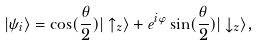Convert formula to latex. <formula><loc_0><loc_0><loc_500><loc_500>| \psi _ { i } \rangle = \cos ( \frac { \theta } { 2 } ) | \uparrow _ { z } \rangle + e ^ { i \varphi } \sin ( \frac { \theta } { 2 } ) | \downarrow _ { z } \rangle ,</formula> 